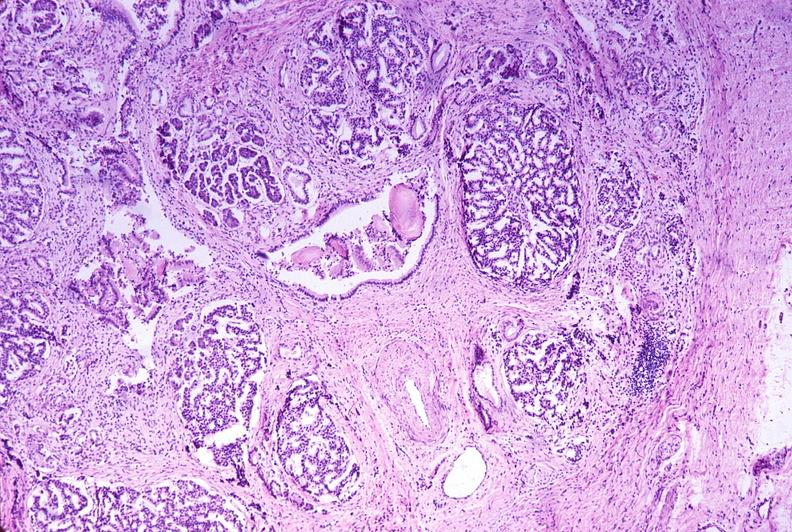where is this?
Answer the question using a single word or phrase. Pancreas 